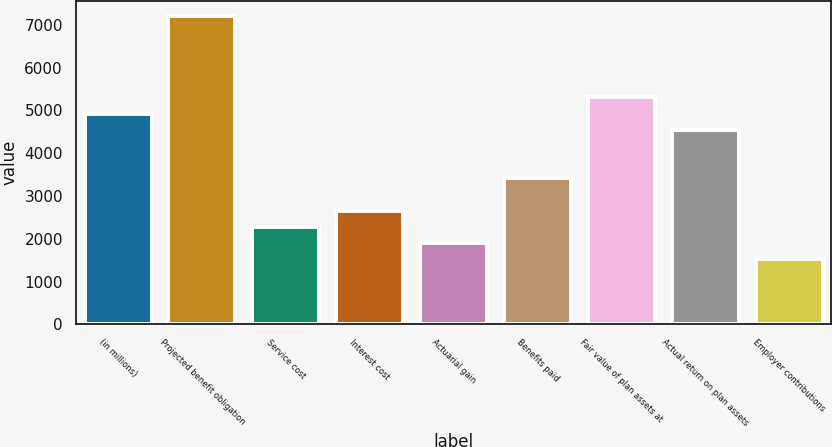Convert chart to OTSL. <chart><loc_0><loc_0><loc_500><loc_500><bar_chart><fcel>(in millions)<fcel>Projected benefit obligation<fcel>Service cost<fcel>Interest cost<fcel>Actuarial gain<fcel>Benefits paid<fcel>Fair value of plan assets at<fcel>Actual return on plan assets<fcel>Employer contributions<nl><fcel>4927.21<fcel>7199.71<fcel>2275.96<fcel>2654.71<fcel>1897.21<fcel>3412.21<fcel>5305.96<fcel>4548.46<fcel>1518.46<nl></chart> 